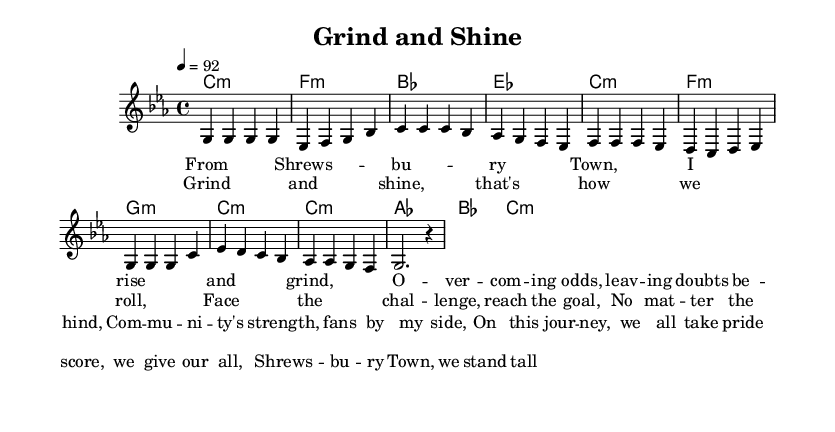What is the key signature of this music? The key signature is indicated at the beginning of the sheet music. In this case, the notation shows that there are three flats, which corresponds to C minor.
Answer: C minor What is the time signature of this music? The time signature is found at the beginning of the score, represented as a fraction. Here, it is shown as 4/4, meaning there are four beats in each measure, and the quarter note gets one beat.
Answer: 4/4 What is the tempo marking in this music? The tempo marking can be found above the staff, written in a specific numeric format. In this example, it indicates a tempo of 92 beats per minute.
Answer: 92 How many measures are there in the chorus section? To find the number of measures, we can count visually in the score. The chorus section spans four measures, as indicated by the grouping in the sheet music.
Answer: 4 What are the main themes expressed in the lyrics? The lyrics focus on overcoming challenges, community support, and striving for goals. Specific lines convey the importance of perseverance and pride in the journey, typical in motivational rap.
Answer: Overcoming challenges, community support What is the relationship between the melody and harmonies in the verse? The melody notes correspond to the chords listed below. Each note in the melody aligns with a chord change in the harmony, establishing support for the vocal line. For instance, the melody starts with C when the harmonies are also in C minor.
Answer: They coincide, supporting the vocal line What genre does this music represent? The style and lyrical content clearly indicate the genre. The rhythmic patterns, cultural references, and motivational themes categorize it firmly as rap music.
Answer: Rap 